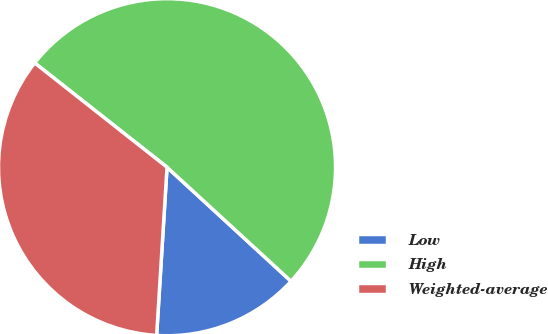Convert chart. <chart><loc_0><loc_0><loc_500><loc_500><pie_chart><fcel>Low<fcel>High<fcel>Weighted-average<nl><fcel>14.15%<fcel>51.21%<fcel>34.64%<nl></chart> 